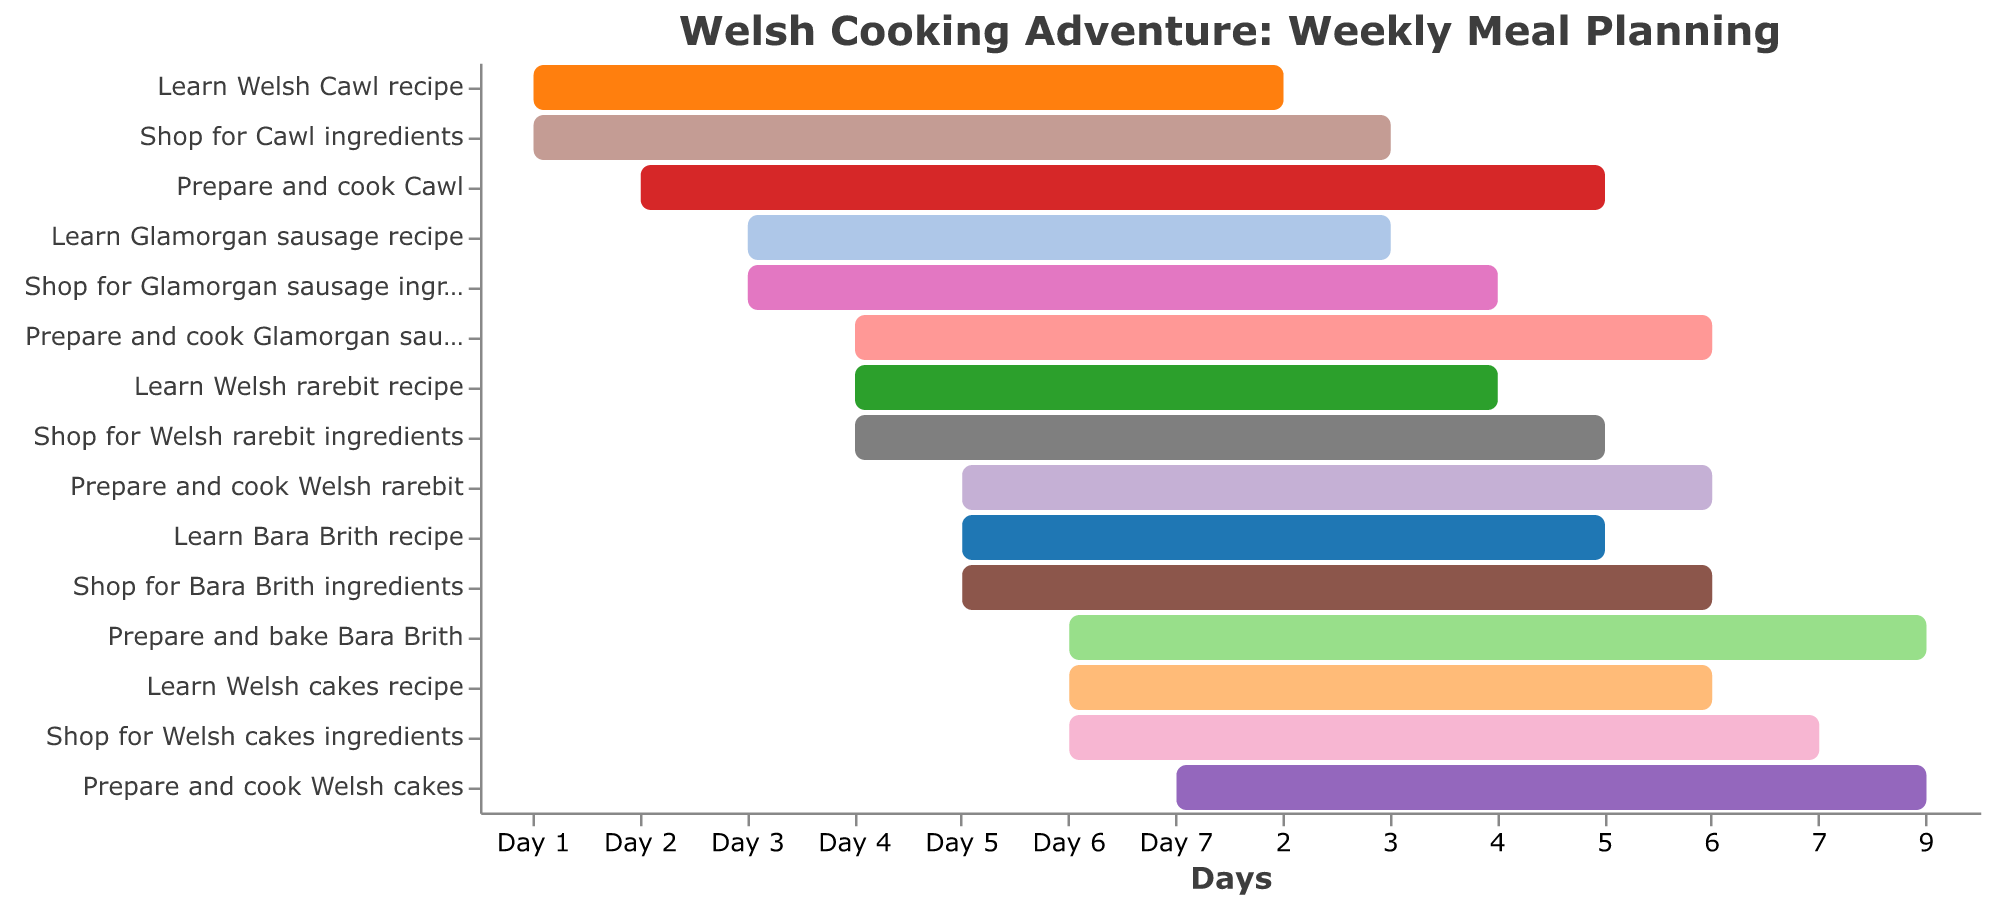What's the title of the chart? The title of the chart is usually at the top and is in a larger font size compared to other text elements in the figure.
Answer: Welsh Cooking Adventure: Weekly Meal Planning On which day do I learn the Welsh Cawl recipe? Look for the task "Learn Welsh Cawl recipe" and identify the corresponding day on the horizontal axis.
Answer: Day 1 How many different tasks are planned on Day 4? Count the number of horizontal bars that start on Day 4.
Answer: 3 Which task takes the longest duration to complete? Compare the lengths of the bars, noting the number of days each task spans.
Answer: Prepare and cook Cawl What is the total duration for learning all recipes? Sum the durations of all tasks that start with "Learn". Add the durations directly.
Answer: 6 days (2 + 1 + 1 + 1 + 1) Which two tasks on Day 5 have a combined duration of 3 days? Look at the tasks scheduled on Day 5, note their individual durations, and find the pair whose combined duration matches 3 days.
Answer: Learn Bara Brith recipe and Prepare and cook Welsh rarebit Are there any tasks planned for Day 7 apart from "Prepare and cook Welsh cakes"? Check the list of tasks corresponding to Day 7 and verify if there are any other tasks listed.
Answer: No On which day do I both learn and shop for Welsh rarebit ingredients? Identify the day where both "Learn Welsh rarebit recipe" and "Shop for Welsh rarebit ingredients" tasks appear.
Answer: Day 4 What is the duration difference between "Prepare and cook Glamorgan sausages" and "Prepare and bake Bara Brith"? Subtract the duration of "Prepare and cook Glamorgan sausages" from the duration of "Prepare and bake Bara Brith".
Answer: 1 day (4 - 3) Which day has the highest number of different tasks? Count the number of tasks for each day, compare, and identify the day with the maximum count.
Answer: Day 6 